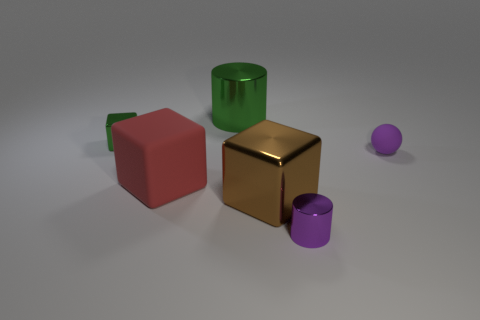Is there anything else that has the same material as the sphere?
Provide a short and direct response. Yes. What size is the thing that is the same color as the small block?
Offer a terse response. Large. Is there any other thing that is the same shape as the tiny matte object?
Make the answer very short. No. Are the small purple sphere and the red cube in front of the small matte ball made of the same material?
Provide a short and direct response. Yes. What color is the metallic cylinder left of the purple object that is in front of the brown cube that is to the right of the red object?
Your answer should be compact. Green. What shape is the shiny object that is the same size as the purple shiny cylinder?
Give a very brief answer. Cube. There is a metal cylinder behind the tiny rubber ball; does it have the same size as the rubber thing that is in front of the purple ball?
Offer a very short reply. Yes. What is the size of the thing that is on the right side of the tiny purple metallic object?
Give a very brief answer. Small. What is the material of the large cylinder that is the same color as the tiny metal block?
Make the answer very short. Metal. There is another rubber block that is the same size as the brown block; what color is it?
Ensure brevity in your answer.  Red. 